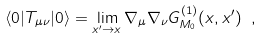<formula> <loc_0><loc_0><loc_500><loc_500>\langle { 0 } | T _ { \mu \nu } | 0 \rangle = \lim _ { x ^ { \prime } \rightarrow { x } } \nabla _ { \mu } \nabla _ { \nu } G ^ { ( 1 ) } _ { M _ { 0 } } ( x , x ^ { \prime } ) \ ,</formula> 